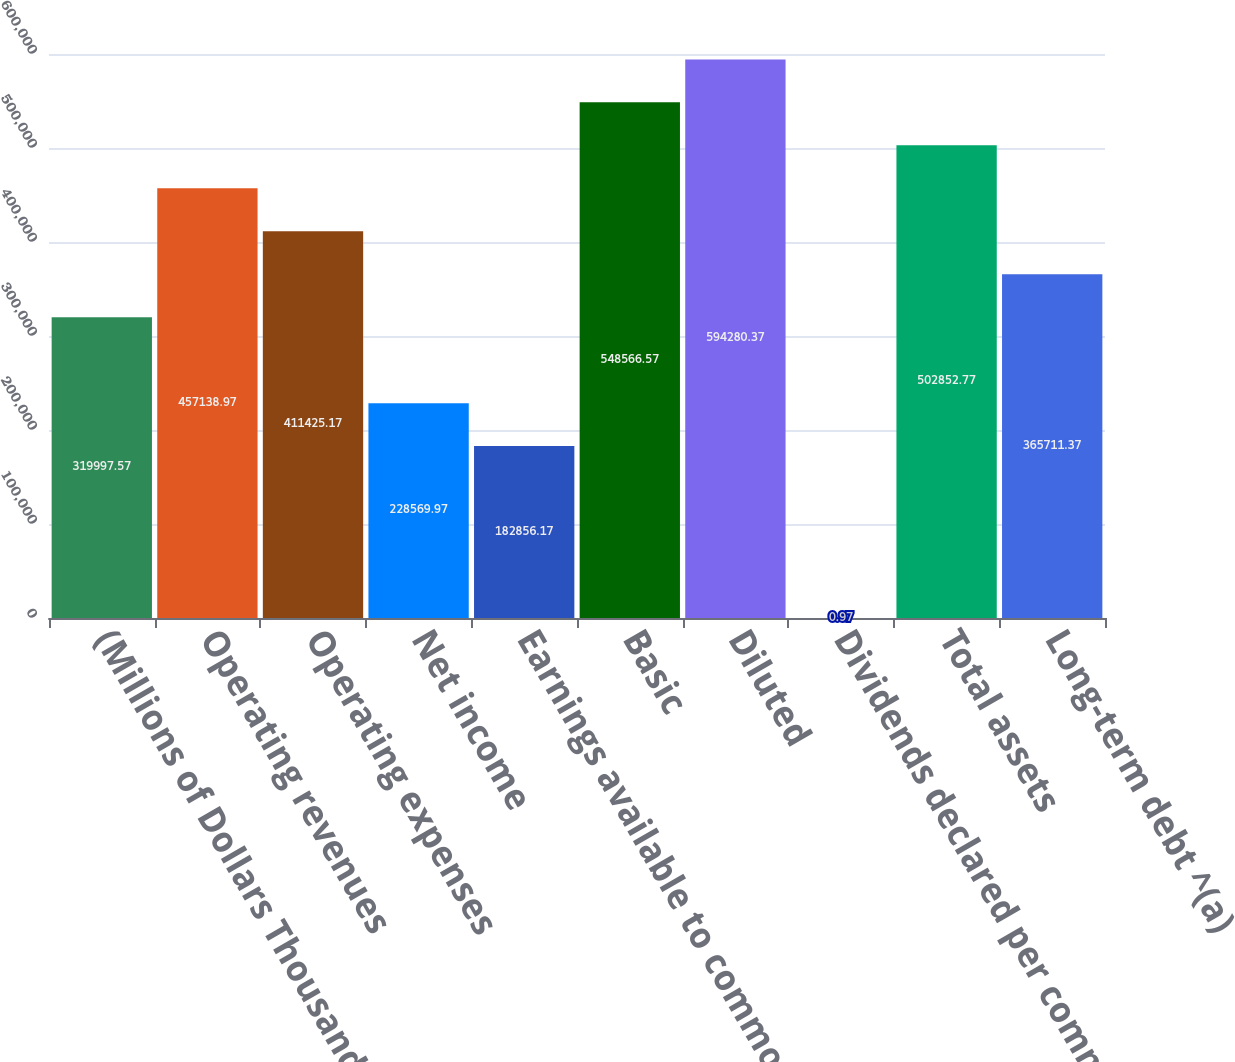<chart> <loc_0><loc_0><loc_500><loc_500><bar_chart><fcel>(Millions of Dollars Thousands<fcel>Operating revenues<fcel>Operating expenses<fcel>Net income<fcel>Earnings available to common<fcel>Basic<fcel>Diluted<fcel>Dividends declared per common<fcel>Total assets<fcel>Long-term debt ^(a)<nl><fcel>319998<fcel>457139<fcel>411425<fcel>228570<fcel>182856<fcel>548567<fcel>594280<fcel>0.97<fcel>502853<fcel>365711<nl></chart> 